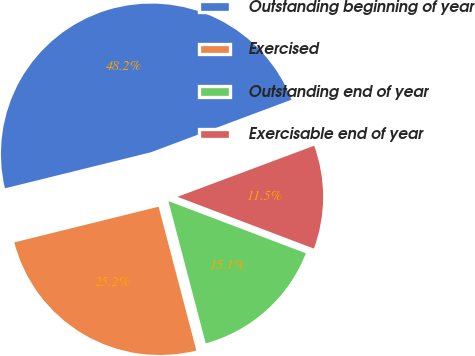Convert chart. <chart><loc_0><loc_0><loc_500><loc_500><pie_chart><fcel>Outstanding beginning of year<fcel>Exercised<fcel>Outstanding end of year<fcel>Exercisable end of year<nl><fcel>48.17%<fcel>25.23%<fcel>15.14%<fcel>11.47%<nl></chart> 